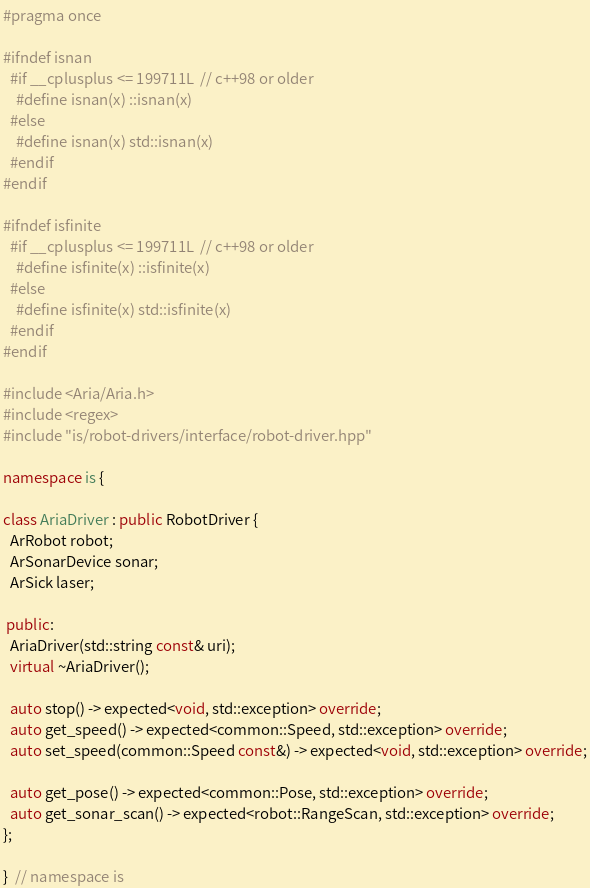<code> <loc_0><loc_0><loc_500><loc_500><_C++_>
#pragma once

#ifndef isnan
  #if __cplusplus <= 199711L  // c++98 or older
    #define isnan(x) ::isnan(x)
  #else
    #define isnan(x) std::isnan(x)
  #endif
#endif

#ifndef isfinite
  #if __cplusplus <= 199711L  // c++98 or older
    #define isfinite(x) ::isfinite(x)
  #else
    #define isfinite(x) std::isfinite(x)
  #endif
#endif

#include <Aria/Aria.h>
#include <regex>
#include "is/robot-drivers/interface/robot-driver.hpp"

namespace is {

class AriaDriver : public RobotDriver {
  ArRobot robot;
  ArSonarDevice sonar;
  ArSick laser;

 public:
  AriaDriver(std::string const& uri);
  virtual ~AriaDriver();

  auto stop() -> expected<void, std::exception> override;
  auto get_speed() -> expected<common::Speed, std::exception> override;
  auto set_speed(common::Speed const&) -> expected<void, std::exception> override;

  auto get_pose() -> expected<common::Pose, std::exception> override;
  auto get_sonar_scan() -> expected<robot::RangeScan, std::exception> override;
};

}  // namespace is</code> 